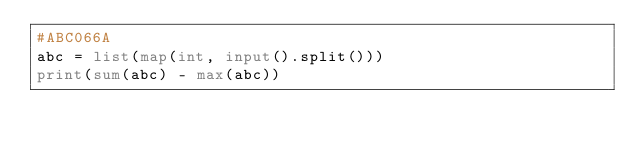Convert code to text. <code><loc_0><loc_0><loc_500><loc_500><_Python_>#ABC066A
abc = list(map(int, input().split()))
print(sum(abc) - max(abc))</code> 